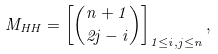Convert formula to latex. <formula><loc_0><loc_0><loc_500><loc_500>M _ { H H } = \left [ \binom { n + 1 } { 2 j - i } \right ] _ { 1 \leq i , j \leq n } ,</formula> 